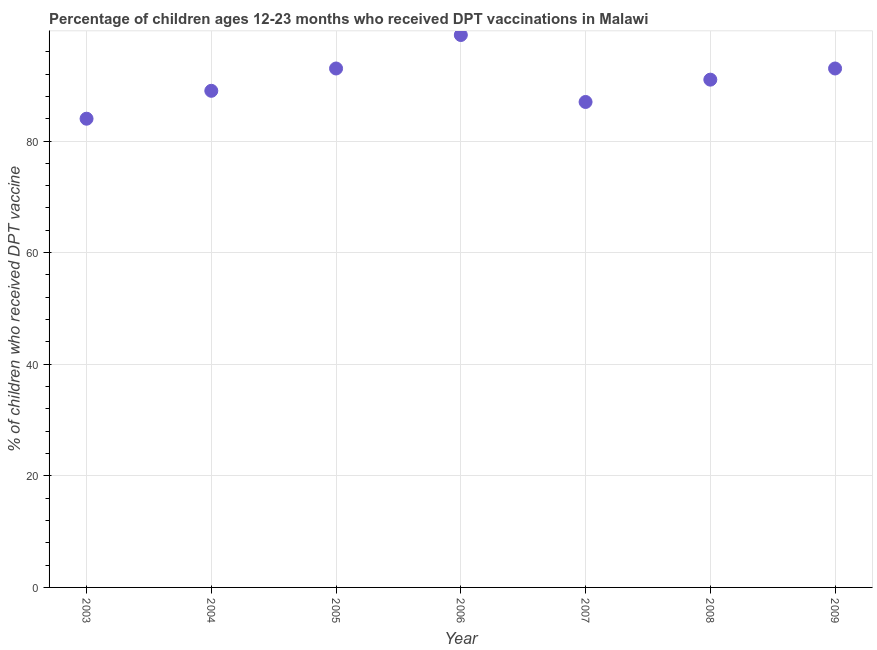What is the percentage of children who received dpt vaccine in 2005?
Give a very brief answer. 93. Across all years, what is the maximum percentage of children who received dpt vaccine?
Offer a very short reply. 99. Across all years, what is the minimum percentage of children who received dpt vaccine?
Provide a succinct answer. 84. In which year was the percentage of children who received dpt vaccine minimum?
Your response must be concise. 2003. What is the sum of the percentage of children who received dpt vaccine?
Your answer should be very brief. 636. What is the difference between the percentage of children who received dpt vaccine in 2007 and 2008?
Give a very brief answer. -4. What is the average percentage of children who received dpt vaccine per year?
Make the answer very short. 90.86. What is the median percentage of children who received dpt vaccine?
Your answer should be very brief. 91. In how many years, is the percentage of children who received dpt vaccine greater than 36 %?
Give a very brief answer. 7. What is the ratio of the percentage of children who received dpt vaccine in 2003 to that in 2008?
Ensure brevity in your answer.  0.92. Is the percentage of children who received dpt vaccine in 2004 less than that in 2007?
Keep it short and to the point. No. What is the difference between the highest and the second highest percentage of children who received dpt vaccine?
Provide a short and direct response. 6. What is the difference between the highest and the lowest percentage of children who received dpt vaccine?
Provide a short and direct response. 15. In how many years, is the percentage of children who received dpt vaccine greater than the average percentage of children who received dpt vaccine taken over all years?
Your answer should be compact. 4. How many dotlines are there?
Ensure brevity in your answer.  1. How many years are there in the graph?
Provide a succinct answer. 7. Are the values on the major ticks of Y-axis written in scientific E-notation?
Offer a very short reply. No. Does the graph contain any zero values?
Provide a short and direct response. No. Does the graph contain grids?
Your response must be concise. Yes. What is the title of the graph?
Your answer should be very brief. Percentage of children ages 12-23 months who received DPT vaccinations in Malawi. What is the label or title of the Y-axis?
Offer a terse response. % of children who received DPT vaccine. What is the % of children who received DPT vaccine in 2004?
Your response must be concise. 89. What is the % of children who received DPT vaccine in 2005?
Give a very brief answer. 93. What is the % of children who received DPT vaccine in 2006?
Ensure brevity in your answer.  99. What is the % of children who received DPT vaccine in 2007?
Your answer should be very brief. 87. What is the % of children who received DPT vaccine in 2008?
Give a very brief answer. 91. What is the % of children who received DPT vaccine in 2009?
Your answer should be very brief. 93. What is the difference between the % of children who received DPT vaccine in 2003 and 2005?
Make the answer very short. -9. What is the difference between the % of children who received DPT vaccine in 2003 and 2007?
Make the answer very short. -3. What is the difference between the % of children who received DPT vaccine in 2003 and 2008?
Your answer should be compact. -7. What is the difference between the % of children who received DPT vaccine in 2004 and 2006?
Ensure brevity in your answer.  -10. What is the difference between the % of children who received DPT vaccine in 2004 and 2007?
Your response must be concise. 2. What is the difference between the % of children who received DPT vaccine in 2005 and 2006?
Keep it short and to the point. -6. What is the difference between the % of children who received DPT vaccine in 2005 and 2007?
Offer a very short reply. 6. What is the difference between the % of children who received DPT vaccine in 2005 and 2008?
Offer a terse response. 2. What is the difference between the % of children who received DPT vaccine in 2005 and 2009?
Your response must be concise. 0. What is the difference between the % of children who received DPT vaccine in 2006 and 2008?
Offer a terse response. 8. What is the difference between the % of children who received DPT vaccine in 2007 and 2009?
Provide a short and direct response. -6. What is the difference between the % of children who received DPT vaccine in 2008 and 2009?
Make the answer very short. -2. What is the ratio of the % of children who received DPT vaccine in 2003 to that in 2004?
Ensure brevity in your answer.  0.94. What is the ratio of the % of children who received DPT vaccine in 2003 to that in 2005?
Provide a short and direct response. 0.9. What is the ratio of the % of children who received DPT vaccine in 2003 to that in 2006?
Your response must be concise. 0.85. What is the ratio of the % of children who received DPT vaccine in 2003 to that in 2007?
Your response must be concise. 0.97. What is the ratio of the % of children who received DPT vaccine in 2003 to that in 2008?
Offer a terse response. 0.92. What is the ratio of the % of children who received DPT vaccine in 2003 to that in 2009?
Ensure brevity in your answer.  0.9. What is the ratio of the % of children who received DPT vaccine in 2004 to that in 2005?
Make the answer very short. 0.96. What is the ratio of the % of children who received DPT vaccine in 2004 to that in 2006?
Ensure brevity in your answer.  0.9. What is the ratio of the % of children who received DPT vaccine in 2004 to that in 2008?
Offer a terse response. 0.98. What is the ratio of the % of children who received DPT vaccine in 2005 to that in 2006?
Your answer should be very brief. 0.94. What is the ratio of the % of children who received DPT vaccine in 2005 to that in 2007?
Offer a very short reply. 1.07. What is the ratio of the % of children who received DPT vaccine in 2005 to that in 2008?
Make the answer very short. 1.02. What is the ratio of the % of children who received DPT vaccine in 2005 to that in 2009?
Ensure brevity in your answer.  1. What is the ratio of the % of children who received DPT vaccine in 2006 to that in 2007?
Provide a succinct answer. 1.14. What is the ratio of the % of children who received DPT vaccine in 2006 to that in 2008?
Offer a very short reply. 1.09. What is the ratio of the % of children who received DPT vaccine in 2006 to that in 2009?
Provide a succinct answer. 1.06. What is the ratio of the % of children who received DPT vaccine in 2007 to that in 2008?
Your answer should be compact. 0.96. What is the ratio of the % of children who received DPT vaccine in 2007 to that in 2009?
Your answer should be compact. 0.94. What is the ratio of the % of children who received DPT vaccine in 2008 to that in 2009?
Keep it short and to the point. 0.98. 